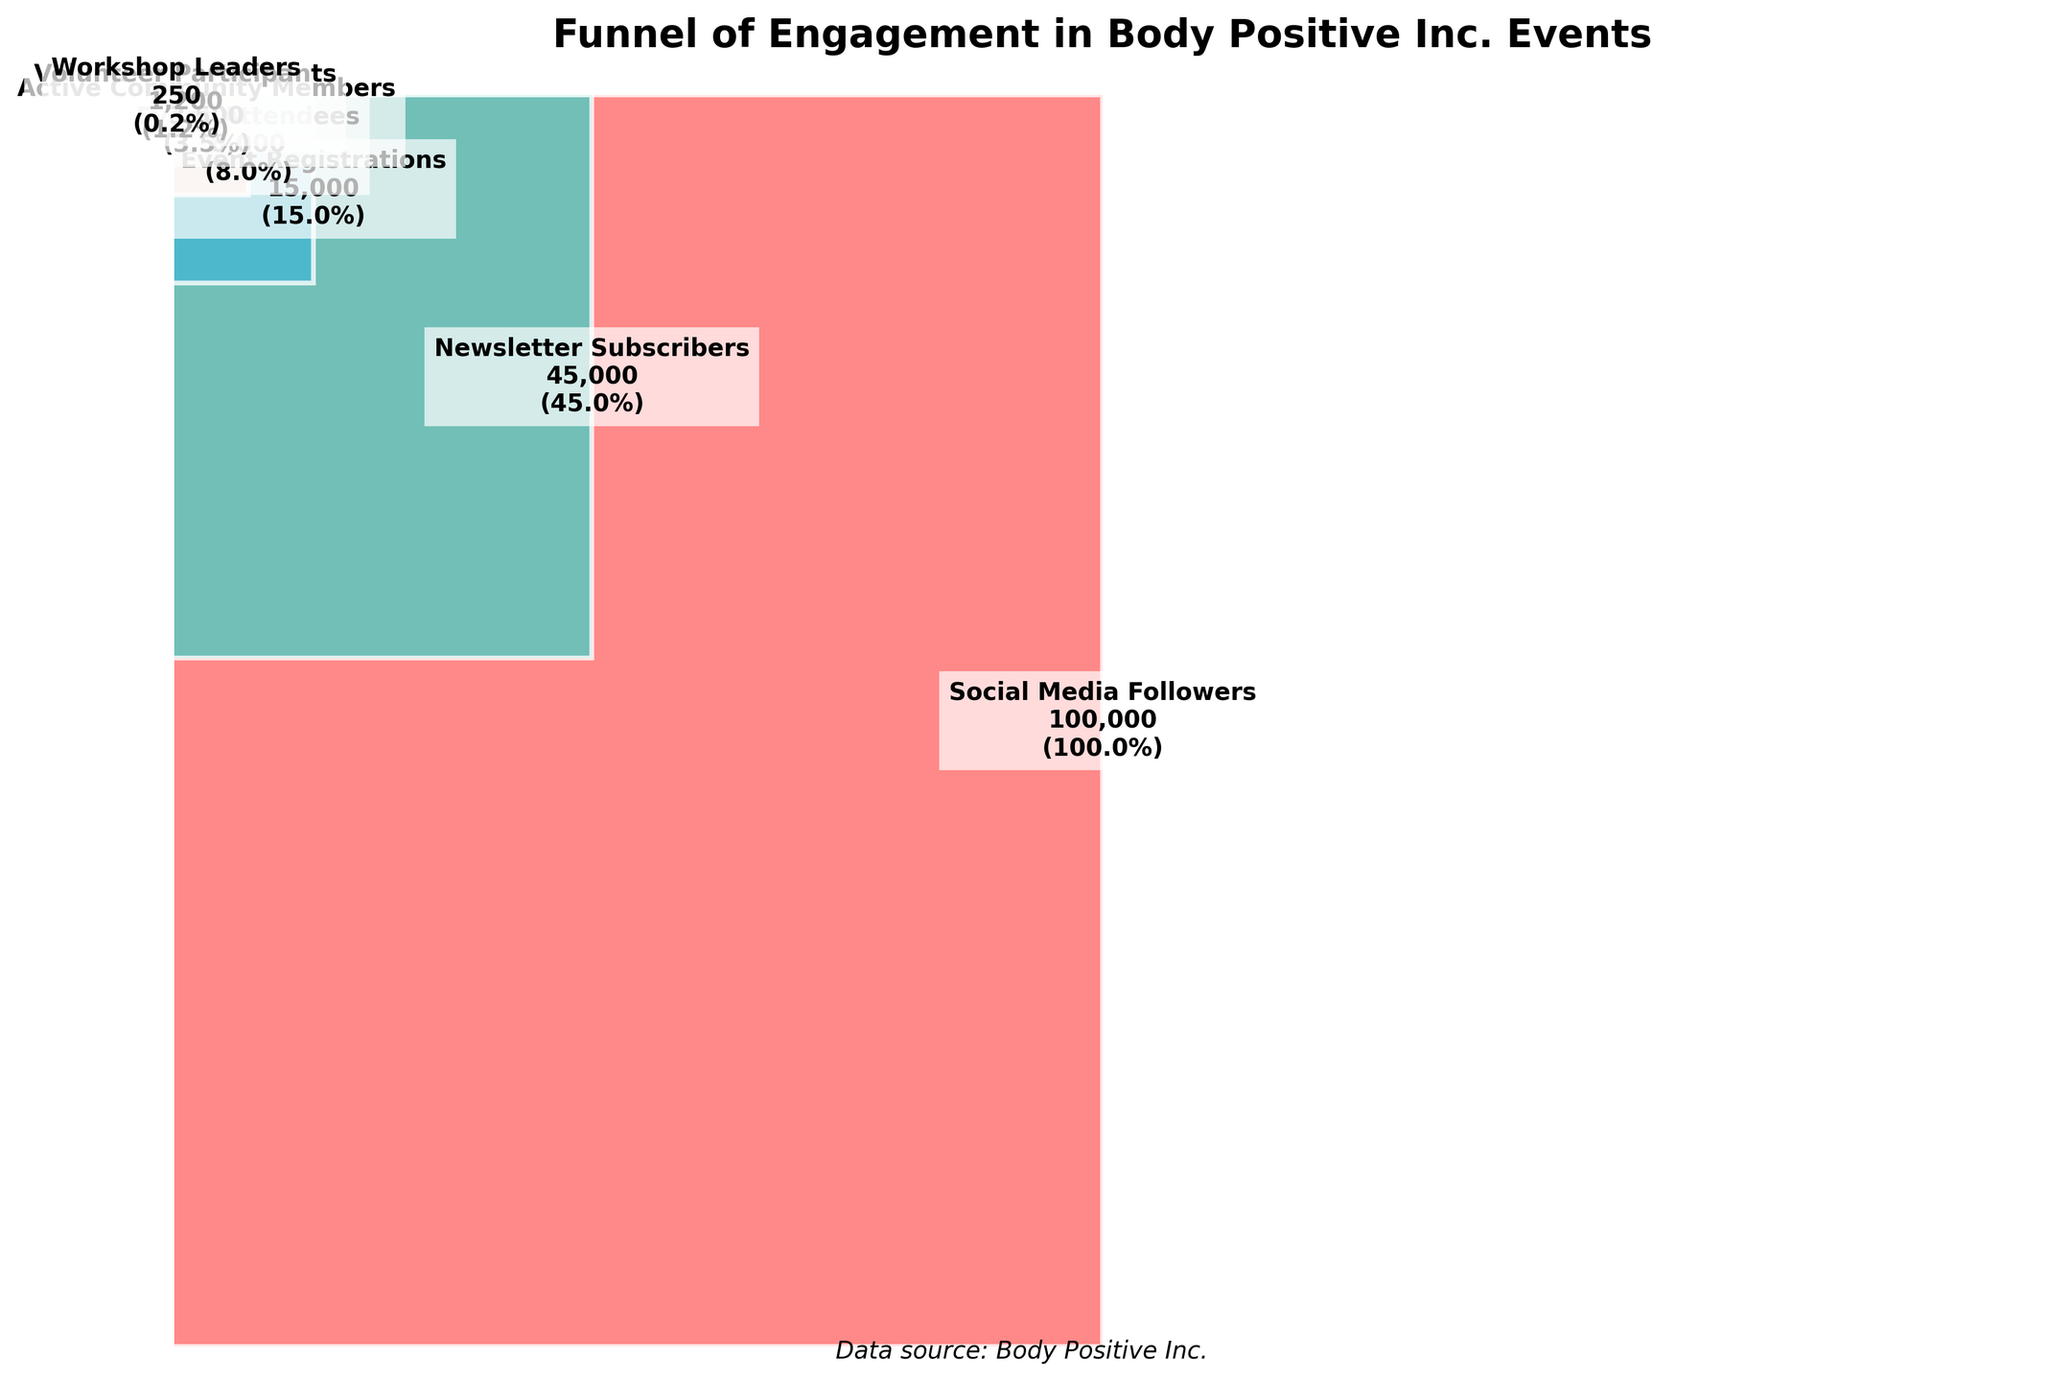What's the title of the funnel chart? The title is displayed at the top of the funnel chart and summarizes the main topic of the chart.
Answer: Funnel of Engagement in Body Positive Inc. Events What is the first stage in the engagement funnel? The first stage is the highest level in the funnel, representing the initial point of engagement.
Answer: Social Media Followers How many people are volunteer participants? The number of people at the "Volunteer Participants" stage is labeled in the corresponding section of the funnel.
Answer: 1,200 What percentage of social media followers become event attendees? To find this percentage, locate the numbers for both "Social Media Followers" and "Event Attendees," then calculate the percentage (8000 / 100000 * 100).
Answer: 8% Which stage has the fewest number of people? The stage with the least number of people is at the narrowest part of the funnel, which usually appears at the bottom.
Answer: Workshop Leaders How many stages are there in the engagement funnel? Count each labeled section in the funnel from top to bottom.
Answer: 7 What is the difference in the number of people between Social Media Followers and Active Community Members? Subtract the number of "Active Community Members" from "Social Media Followers" (100000 - 3500).
Answer: 96,500 How do the sizes of the event registrations and event attendees compare? Compare the numbers in the "Event Registrations" and "Event Attendees" stages by examining their values directly from the labels.
Answer: There are fewer event attendees than event registrations What is the approximate percentage of newsletter subscribers who eventually become active community members? Divide the number of "Active Community Members" by "Newsletter Subscribers" and multiply by 100 (3500 / 45000 * 100).
Answer: 7.78% What is the largest drop in engagement between any two consecutive stages? Calculate the differences between consecutive stages and identify the largest drop. The largest drop is from "Newsletter Subscribers" to "Event Registrations" (45000 - 15000).
Answer: 30,000 